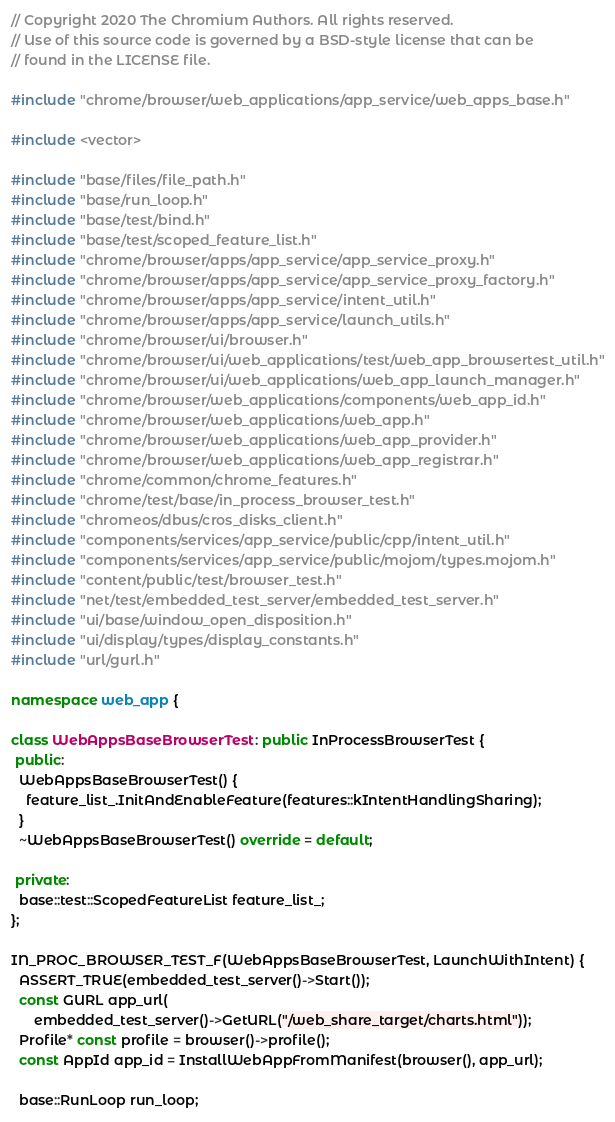<code> <loc_0><loc_0><loc_500><loc_500><_C++_>// Copyright 2020 The Chromium Authors. All rights reserved.
// Use of this source code is governed by a BSD-style license that can be
// found in the LICENSE file.

#include "chrome/browser/web_applications/app_service/web_apps_base.h"

#include <vector>

#include "base/files/file_path.h"
#include "base/run_loop.h"
#include "base/test/bind.h"
#include "base/test/scoped_feature_list.h"
#include "chrome/browser/apps/app_service/app_service_proxy.h"
#include "chrome/browser/apps/app_service/app_service_proxy_factory.h"
#include "chrome/browser/apps/app_service/intent_util.h"
#include "chrome/browser/apps/app_service/launch_utils.h"
#include "chrome/browser/ui/browser.h"
#include "chrome/browser/ui/web_applications/test/web_app_browsertest_util.h"
#include "chrome/browser/ui/web_applications/web_app_launch_manager.h"
#include "chrome/browser/web_applications/components/web_app_id.h"
#include "chrome/browser/web_applications/web_app.h"
#include "chrome/browser/web_applications/web_app_provider.h"
#include "chrome/browser/web_applications/web_app_registrar.h"
#include "chrome/common/chrome_features.h"
#include "chrome/test/base/in_process_browser_test.h"
#include "chromeos/dbus/cros_disks_client.h"
#include "components/services/app_service/public/cpp/intent_util.h"
#include "components/services/app_service/public/mojom/types.mojom.h"
#include "content/public/test/browser_test.h"
#include "net/test/embedded_test_server/embedded_test_server.h"
#include "ui/base/window_open_disposition.h"
#include "ui/display/types/display_constants.h"
#include "url/gurl.h"

namespace web_app {

class WebAppsBaseBrowserTest : public InProcessBrowserTest {
 public:
  WebAppsBaseBrowserTest() {
    feature_list_.InitAndEnableFeature(features::kIntentHandlingSharing);
  }
  ~WebAppsBaseBrowserTest() override = default;

 private:
  base::test::ScopedFeatureList feature_list_;
};

IN_PROC_BROWSER_TEST_F(WebAppsBaseBrowserTest, LaunchWithIntent) {
  ASSERT_TRUE(embedded_test_server()->Start());
  const GURL app_url(
      embedded_test_server()->GetURL("/web_share_target/charts.html"));
  Profile* const profile = browser()->profile();
  const AppId app_id = InstallWebAppFromManifest(browser(), app_url);

  base::RunLoop run_loop;</code> 